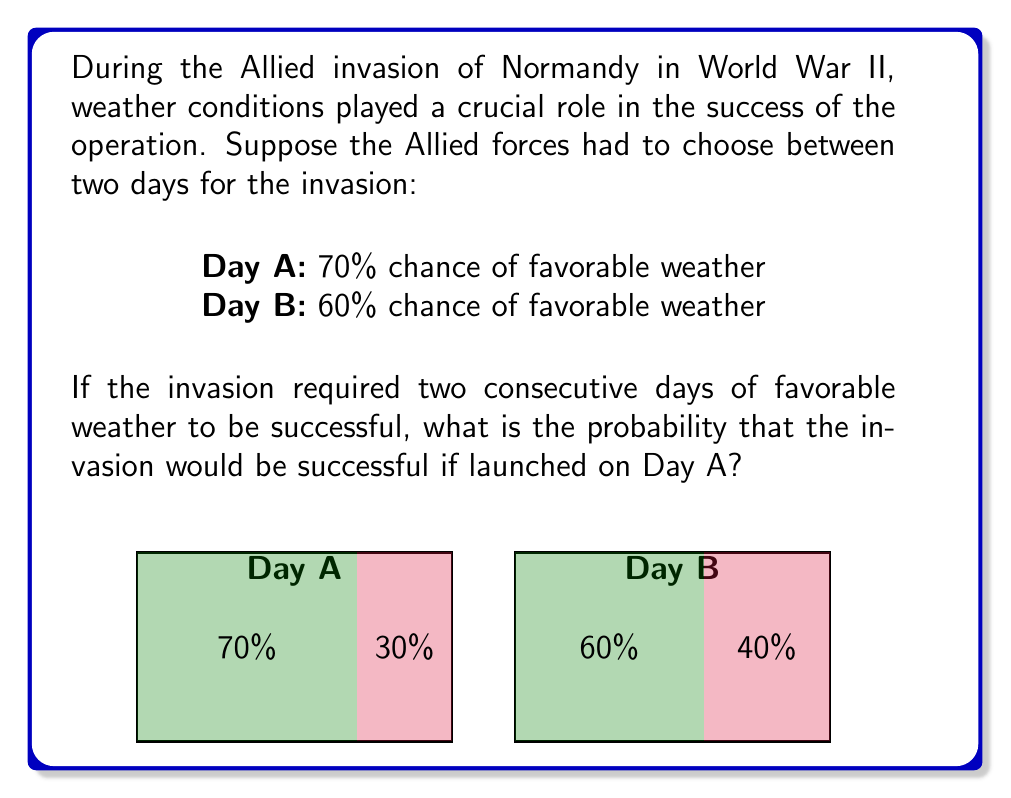What is the answer to this math problem? To solve this problem, we need to calculate the probability of having favorable weather on both Day A and Day B. Let's break it down step-by-step:

1) The probability of favorable weather on Day A is 70% or 0.7
2) The probability of favorable weather on Day B is 60% or 0.6

3) For the invasion to be successful, we need favorable weather on both days. In probability theory, when we need two independent events to both occur, we multiply their individual probabilities.

4) Let's define our events:
   A: Favorable weather on Day A
   B: Favorable weather on Day B

5) We want to calculate P(A and B):
   
   $$P(A \text{ and } B) = P(A) \times P(B)$$

6) Substituting our values:

   $$P(A \text{ and } B) = 0.7 \times 0.6$$

7) Calculating:

   $$P(A \text{ and } B) = 0.42$$

8) Convert to a percentage:

   $$0.42 \times 100\% = 42\%$$

Therefore, if the Allied forces launched the invasion on Day A, there would be a 42% chance of having favorable weather for two consecutive days, making the invasion successful.
Answer: 42% 